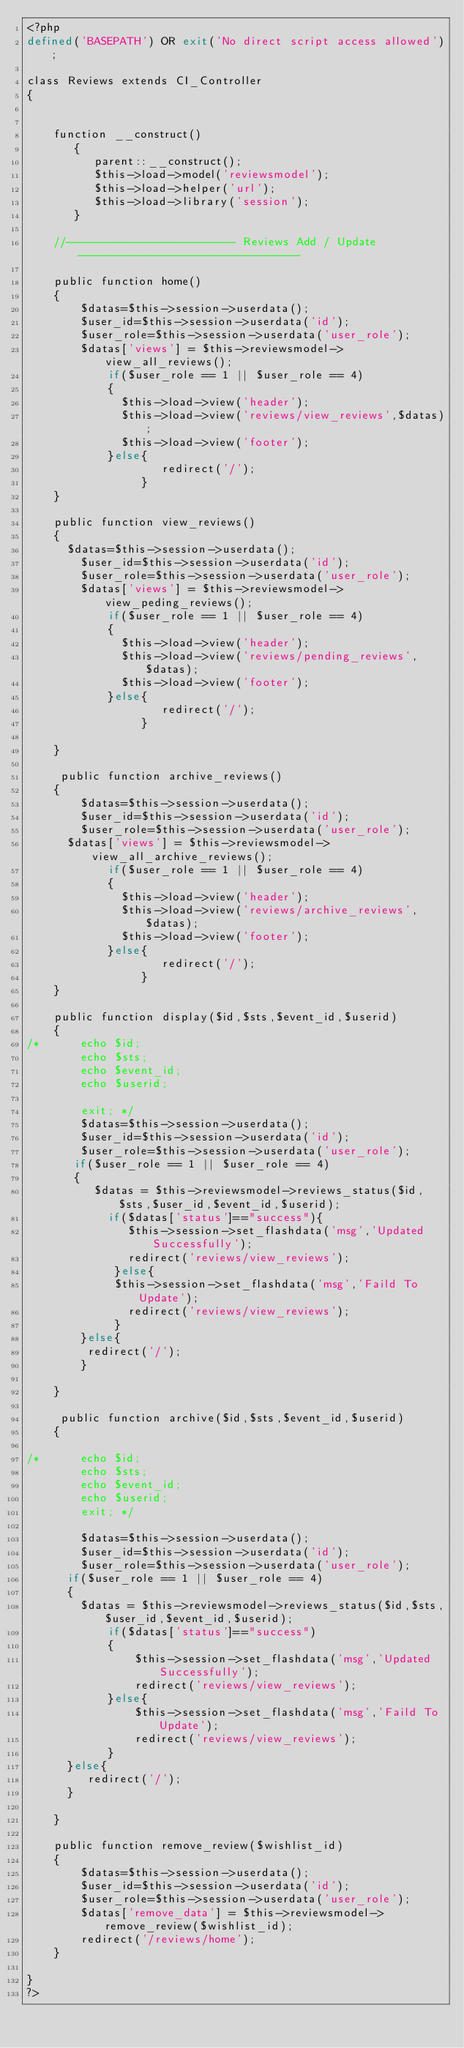<code> <loc_0><loc_0><loc_500><loc_500><_PHP_><?php
defined('BASEPATH') OR exit('No direct script access allowed');

class Reviews extends CI_Controller
{


	function __construct()
	   {
		  parent::__construct();
		  $this->load->model('reviewsmodel');
		  $this->load->helper('url');
		  $this->load->library('session');
       }

    //------------------------- Reviews Add / Update---------------------------------

    public function home()
    {
    	$datas=$this->session->userdata();
	    $user_id=$this->session->userdata('id');
	    $user_role=$this->session->userdata('user_role');
		$datas['views'] = $this->reviewsmodel->view_all_reviews();
			if($user_role == 1 || $user_role == 4)
			{
			  $this->load->view('header');
			  $this->load->view('reviews/view_reviews',$datas);
			  $this->load->view('footer');
		 	}else{
		 			redirect('/');
		 		 }
    }

    public function view_reviews()
    {
      $datas=$this->session->userdata();
	    $user_id=$this->session->userdata('id');
	    $user_role=$this->session->userdata('user_role');
		$datas['views'] = $this->reviewsmodel->view_peding_reviews();
			if($user_role == 1 || $user_role == 4)
			{
			  $this->load->view('header');
			  $this->load->view('reviews/pending_reviews',$datas);
			  $this->load->view('footer');
		 	}else{
		 			redirect('/');
		 		 }

    }
	
	 public function archive_reviews()
    {
    	$datas=$this->session->userdata();
	    $user_id=$this->session->userdata('id');
	    $user_role=$this->session->userdata('user_role');
      $datas['views'] = $this->reviewsmodel->view_all_archive_reviews();
			if($user_role == 1 || $user_role == 4)
			{
			  $this->load->view('header');
			  $this->load->view('reviews/archive_reviews',$datas);
			  $this->load->view('footer');
		 	}else{
		 			redirect('/');
		 		 }
    }
	
    public function display($id,$sts,$event_id,$userid)
    {
/* 		echo $id;
		echo $sts;
		echo $event_id;
		echo $userid;
		
		exit; */
    	$datas=$this->session->userdata();
	    $user_id=$this->session->userdata('id');
	    $user_role=$this->session->userdata('user_role');
       if($user_role == 1 || $user_role == 4)
       {
		  $datas = $this->reviewsmodel->reviews_status($id,$sts,$user_id,$event_id,$userid);
			if($datas['status']=="success"){
		       $this->session->set_flashdata('msg','Updated Successfully');
			   redirect('reviews/view_reviews');
		     }else{
	         $this->session->set_flashdata('msg','Faild To Update');
			   redirect('reviews/view_reviews');
	         }
        }else{
       	 redirect('/');
        }

    }

     public function archive($id,$sts,$event_id,$userid)
    {
		
/* 		echo $id;
		echo $sts;
		echo $event_id;
		echo $userid;
		exit; */
		
    	$datas=$this->session->userdata();
	    $user_id=$this->session->userdata('id');
	    $user_role=$this->session->userdata('user_role');
      if($user_role == 1 || $user_role == 4)
      {
		$datas = $this->reviewsmodel->reviews_status($id,$sts,$user_id,$event_id,$userid);
			if($datas['status']=="success")
			{
				$this->session->set_flashdata('msg','Updated Successfully');
				redirect('reviews/view_reviews');
			}else{
				$this->session->set_flashdata('msg','Faild To Update');
				redirect('reviews/view_reviews');
			}
      }else{
     	 redirect('/');
      }

    }

	public function remove_review($wishlist_id)
	{
		$datas=$this->session->userdata();
		$user_id=$this->session->userdata('id');
		$user_role=$this->session->userdata('user_role');
		$datas['remove_data'] = $this->reviewsmodel->remove_review($wishlist_id);
		redirect('/reviews/home');
	}
   
}
?>
</code> 